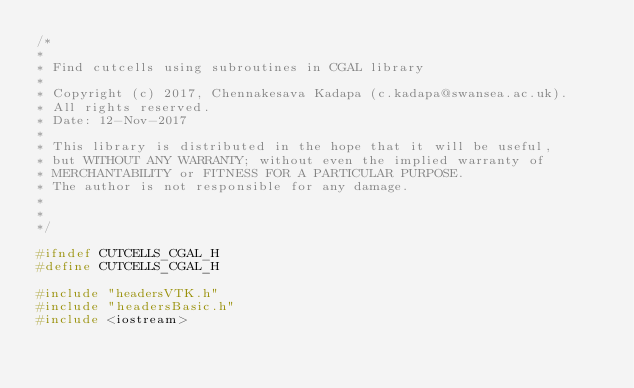Convert code to text. <code><loc_0><loc_0><loc_500><loc_500><_C_>/*
*
* Find cutcells using subroutines in CGAL library
*
* Copyright (c) 2017, Chennakesava Kadapa (c.kadapa@swansea.ac.uk).
* All rights reserved.
* Date: 12-Nov-2017
*
* This library is distributed in the hope that it will be useful,
* but WITHOUT ANY WARRANTY; without even the implied warranty of
* MERCHANTABILITY or FITNESS FOR A PARTICULAR PURPOSE.
* The author is not responsible for any damage.
*
*
*/

#ifndef CUTCELLS_CGAL_H
#define CUTCELLS_CGAL_H

#include "headersVTK.h"
#include "headersBasic.h"
#include <iostream></code> 